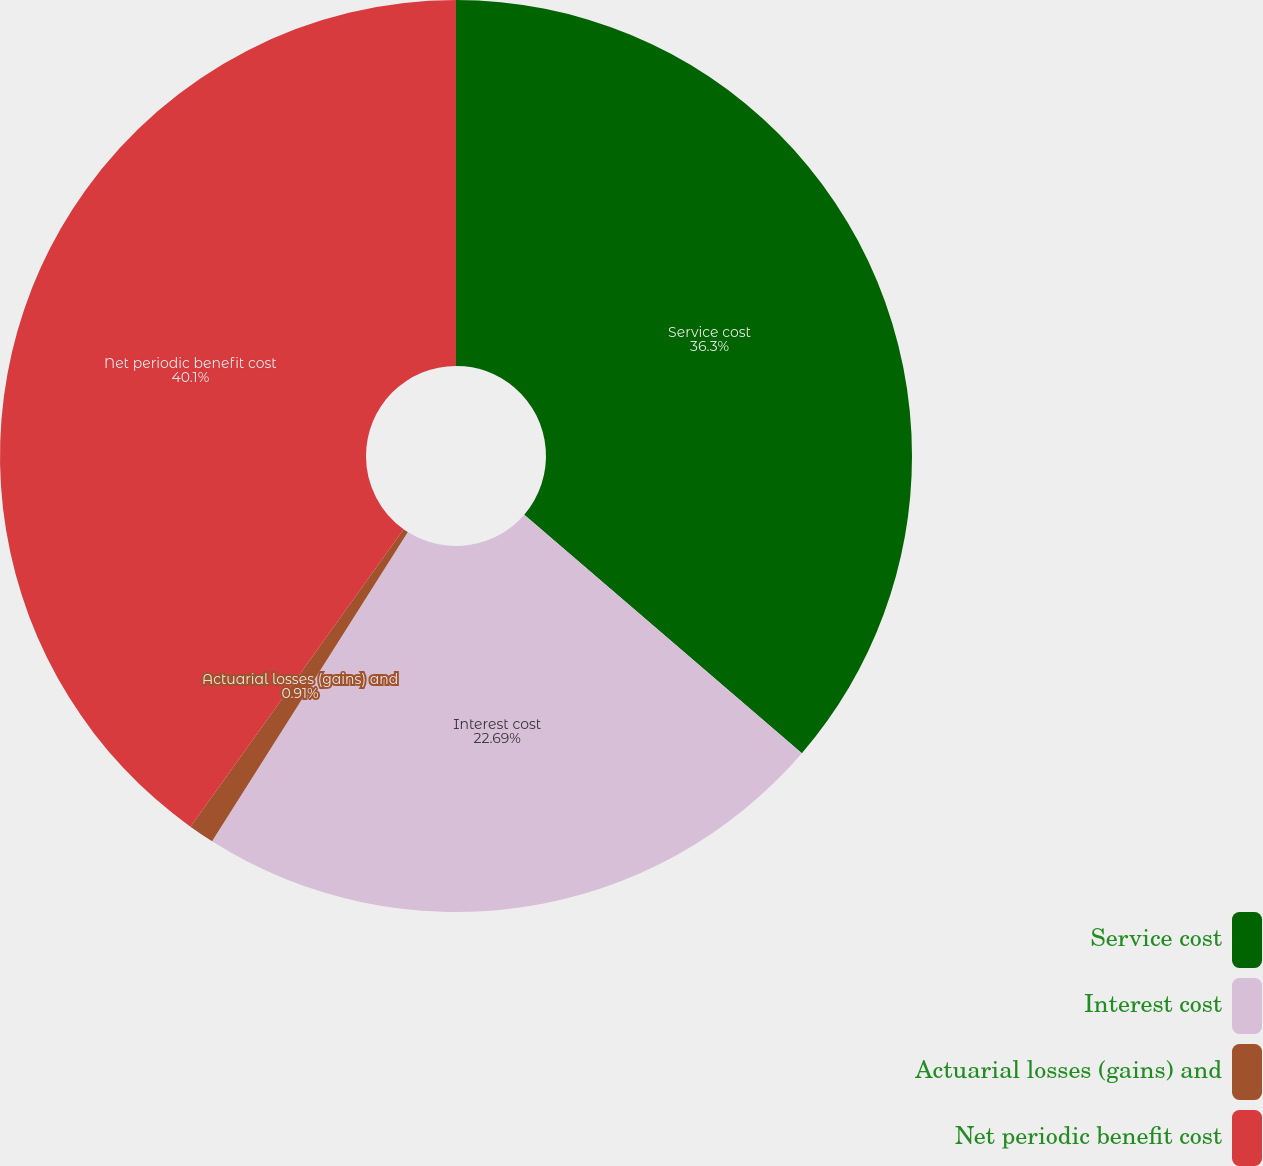Convert chart. <chart><loc_0><loc_0><loc_500><loc_500><pie_chart><fcel>Service cost<fcel>Interest cost<fcel>Actuarial losses (gains) and<fcel>Net periodic benefit cost<nl><fcel>36.3%<fcel>22.69%<fcel>0.91%<fcel>40.11%<nl></chart> 